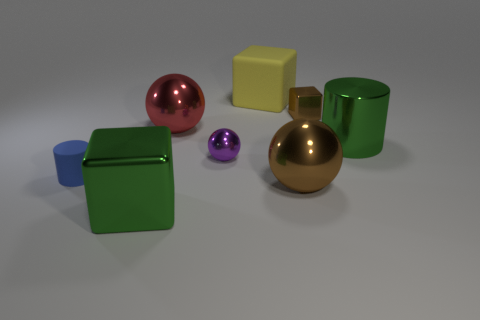Add 1 large gray shiny things. How many objects exist? 9 Subtract all spheres. How many objects are left? 5 Add 6 tiny metal cubes. How many tiny metal cubes exist? 7 Subtract 0 yellow cylinders. How many objects are left? 8 Subtract all tiny brown cubes. Subtract all big red metallic spheres. How many objects are left? 6 Add 2 brown shiny blocks. How many brown shiny blocks are left? 3 